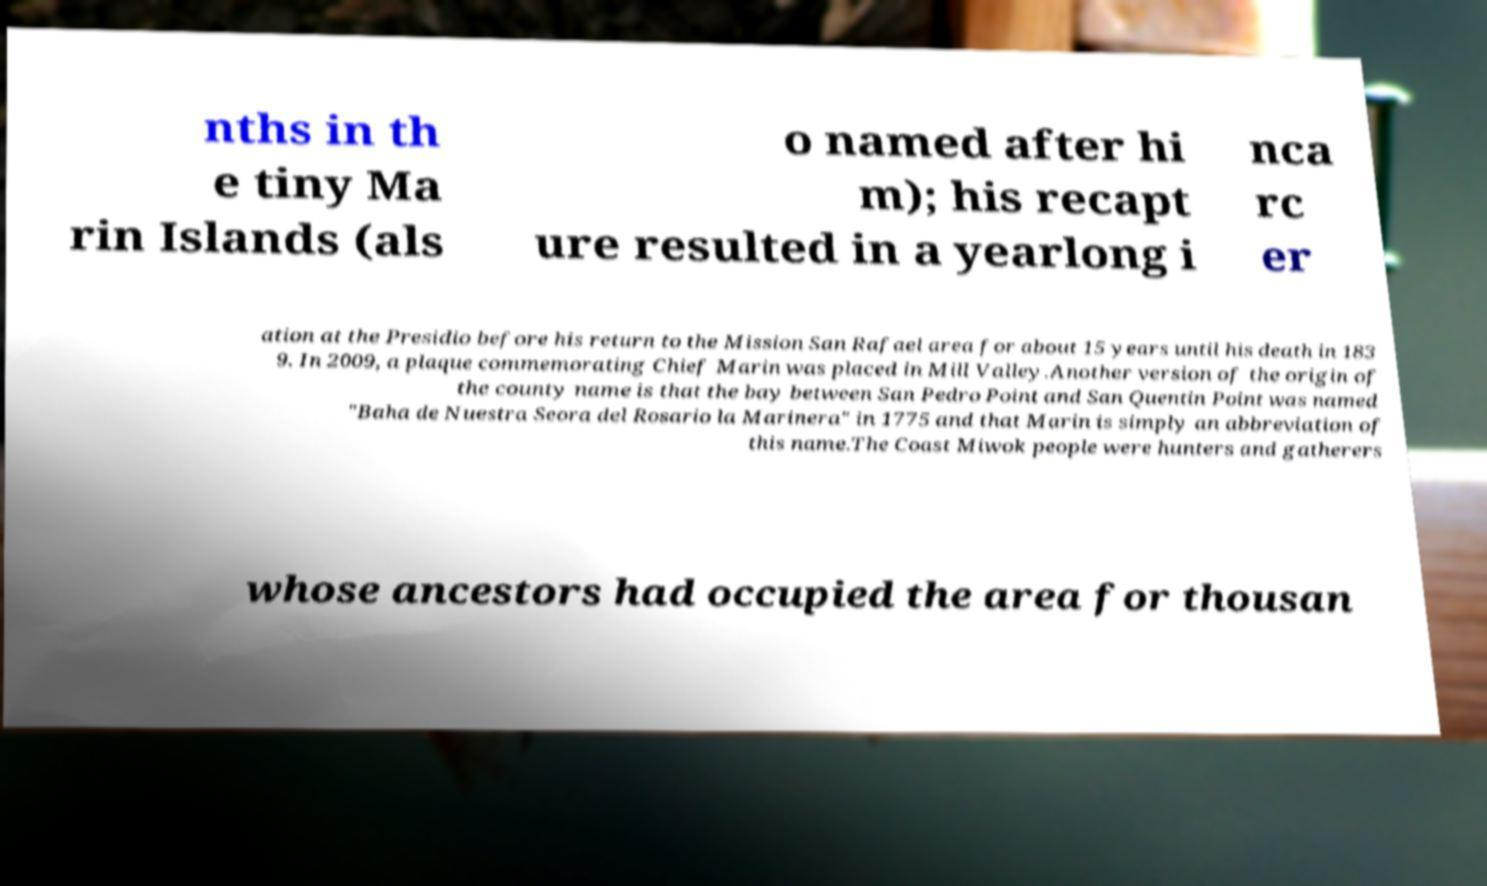Can you read and provide the text displayed in the image?This photo seems to have some interesting text. Can you extract and type it out for me? nths in th e tiny Ma rin Islands (als o named after hi m); his recapt ure resulted in a yearlong i nca rc er ation at the Presidio before his return to the Mission San Rafael area for about 15 years until his death in 183 9. In 2009, a plaque commemorating Chief Marin was placed in Mill Valley.Another version of the origin of the county name is that the bay between San Pedro Point and San Quentin Point was named "Baha de Nuestra Seora del Rosario la Marinera" in 1775 and that Marin is simply an abbreviation of this name.The Coast Miwok people were hunters and gatherers whose ancestors had occupied the area for thousan 